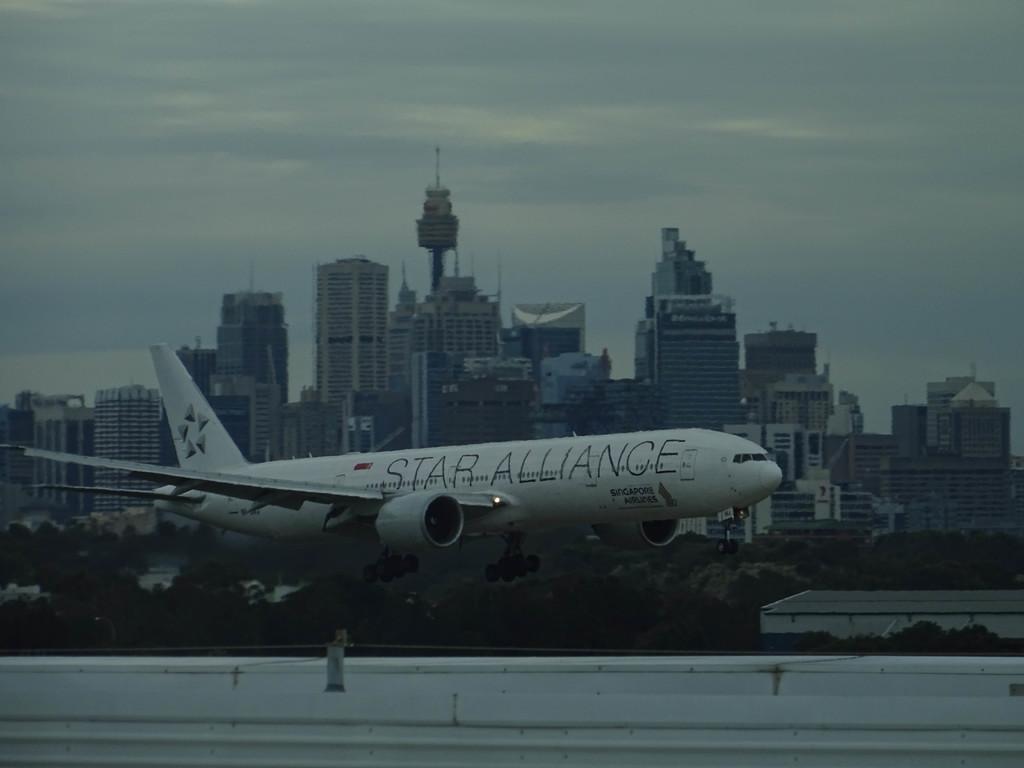What is the airline?
Your response must be concise. Star alliance. 